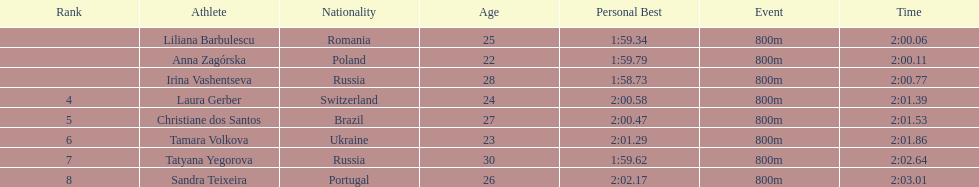In regards to anna zagorska, what was her finishing time? 2:00.11. 